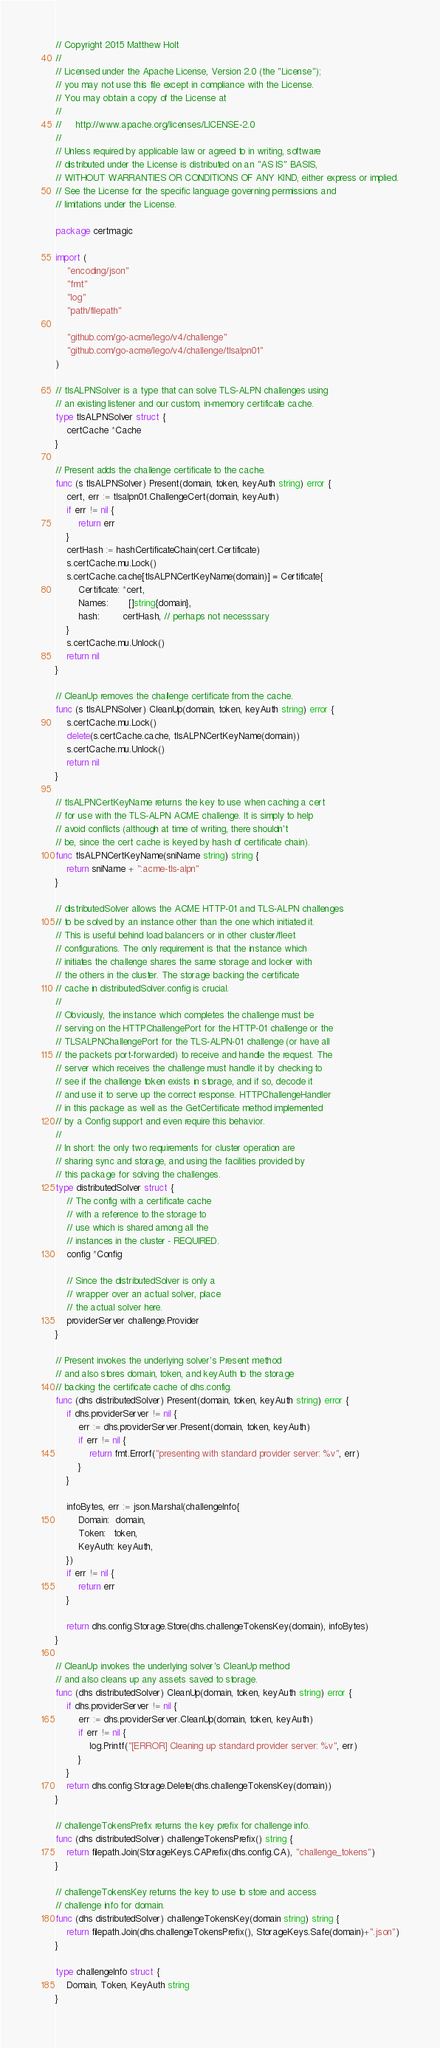Convert code to text. <code><loc_0><loc_0><loc_500><loc_500><_Go_>// Copyright 2015 Matthew Holt
//
// Licensed under the Apache License, Version 2.0 (the "License");
// you may not use this file except in compliance with the License.
// You may obtain a copy of the License at
//
//     http://www.apache.org/licenses/LICENSE-2.0
//
// Unless required by applicable law or agreed to in writing, software
// distributed under the License is distributed on an "AS IS" BASIS,
// WITHOUT WARRANTIES OR CONDITIONS OF ANY KIND, either express or implied.
// See the License for the specific language governing permissions and
// limitations under the License.

package certmagic

import (
	"encoding/json"
	"fmt"
	"log"
	"path/filepath"

	"github.com/go-acme/lego/v4/challenge"
	"github.com/go-acme/lego/v4/challenge/tlsalpn01"
)

// tlsALPNSolver is a type that can solve TLS-ALPN challenges using
// an existing listener and our custom, in-memory certificate cache.
type tlsALPNSolver struct {
	certCache *Cache
}

// Present adds the challenge certificate to the cache.
func (s tlsALPNSolver) Present(domain, token, keyAuth string) error {
	cert, err := tlsalpn01.ChallengeCert(domain, keyAuth)
	if err != nil {
		return err
	}
	certHash := hashCertificateChain(cert.Certificate)
	s.certCache.mu.Lock()
	s.certCache.cache[tlsALPNCertKeyName(domain)] = Certificate{
		Certificate: *cert,
		Names:       []string{domain},
		hash:        certHash, // perhaps not necesssary
	}
	s.certCache.mu.Unlock()
	return nil
}

// CleanUp removes the challenge certificate from the cache.
func (s tlsALPNSolver) CleanUp(domain, token, keyAuth string) error {
	s.certCache.mu.Lock()
	delete(s.certCache.cache, tlsALPNCertKeyName(domain))
	s.certCache.mu.Unlock()
	return nil
}

// tlsALPNCertKeyName returns the key to use when caching a cert
// for use with the TLS-ALPN ACME challenge. It is simply to help
// avoid conflicts (although at time of writing, there shouldn't
// be, since the cert cache is keyed by hash of certificate chain).
func tlsALPNCertKeyName(sniName string) string {
	return sniName + ":acme-tls-alpn"
}

// distributedSolver allows the ACME HTTP-01 and TLS-ALPN challenges
// to be solved by an instance other than the one which initiated it.
// This is useful behind load balancers or in other cluster/fleet
// configurations. The only requirement is that the instance which
// initiates the challenge shares the same storage and locker with
// the others in the cluster. The storage backing the certificate
// cache in distributedSolver.config is crucial.
//
// Obviously, the instance which completes the challenge must be
// serving on the HTTPChallengePort for the HTTP-01 challenge or the
// TLSALPNChallengePort for the TLS-ALPN-01 challenge (or have all
// the packets port-forwarded) to receive and handle the request. The
// server which receives the challenge must handle it by checking to
// see if the challenge token exists in storage, and if so, decode it
// and use it to serve up the correct response. HTTPChallengeHandler
// in this package as well as the GetCertificate method implemented
// by a Config support and even require this behavior.
//
// In short: the only two requirements for cluster operation are
// sharing sync and storage, and using the facilities provided by
// this package for solving the challenges.
type distributedSolver struct {
	// The config with a certificate cache
	// with a reference to the storage to
	// use which is shared among all the
	// instances in the cluster - REQUIRED.
	config *Config

	// Since the distributedSolver is only a
	// wrapper over an actual solver, place
	// the actual solver here.
	providerServer challenge.Provider
}

// Present invokes the underlying solver's Present method
// and also stores domain, token, and keyAuth to the storage
// backing the certificate cache of dhs.config.
func (dhs distributedSolver) Present(domain, token, keyAuth string) error {
	if dhs.providerServer != nil {
		err := dhs.providerServer.Present(domain, token, keyAuth)
		if err != nil {
			return fmt.Errorf("presenting with standard provider server: %v", err)
		}
	}

	infoBytes, err := json.Marshal(challengeInfo{
		Domain:  domain,
		Token:   token,
		KeyAuth: keyAuth,
	})
	if err != nil {
		return err
	}

	return dhs.config.Storage.Store(dhs.challengeTokensKey(domain), infoBytes)
}

// CleanUp invokes the underlying solver's CleanUp method
// and also cleans up any assets saved to storage.
func (dhs distributedSolver) CleanUp(domain, token, keyAuth string) error {
	if dhs.providerServer != nil {
		err := dhs.providerServer.CleanUp(domain, token, keyAuth)
		if err != nil {
			log.Printf("[ERROR] Cleaning up standard provider server: %v", err)
		}
	}
	return dhs.config.Storage.Delete(dhs.challengeTokensKey(domain))
}

// challengeTokensPrefix returns the key prefix for challenge info.
func (dhs distributedSolver) challengeTokensPrefix() string {
	return filepath.Join(StorageKeys.CAPrefix(dhs.config.CA), "challenge_tokens")
}

// challengeTokensKey returns the key to use to store and access
// challenge info for domain.
func (dhs distributedSolver) challengeTokensKey(domain string) string {
	return filepath.Join(dhs.challengeTokensPrefix(), StorageKeys.Safe(domain)+".json")
}

type challengeInfo struct {
	Domain, Token, KeyAuth string
}
</code> 